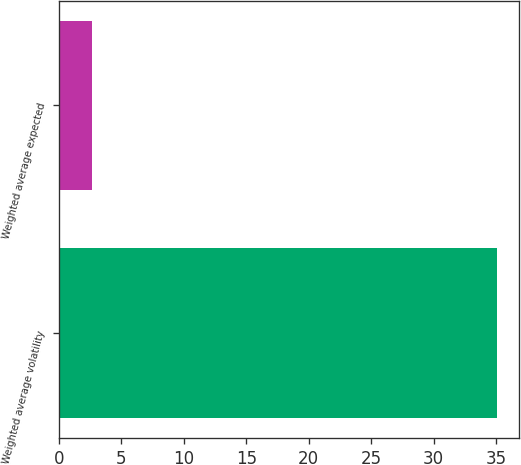<chart> <loc_0><loc_0><loc_500><loc_500><bar_chart><fcel>Weighted average volatility<fcel>Weighted average expected<nl><fcel>35.1<fcel>2.7<nl></chart> 